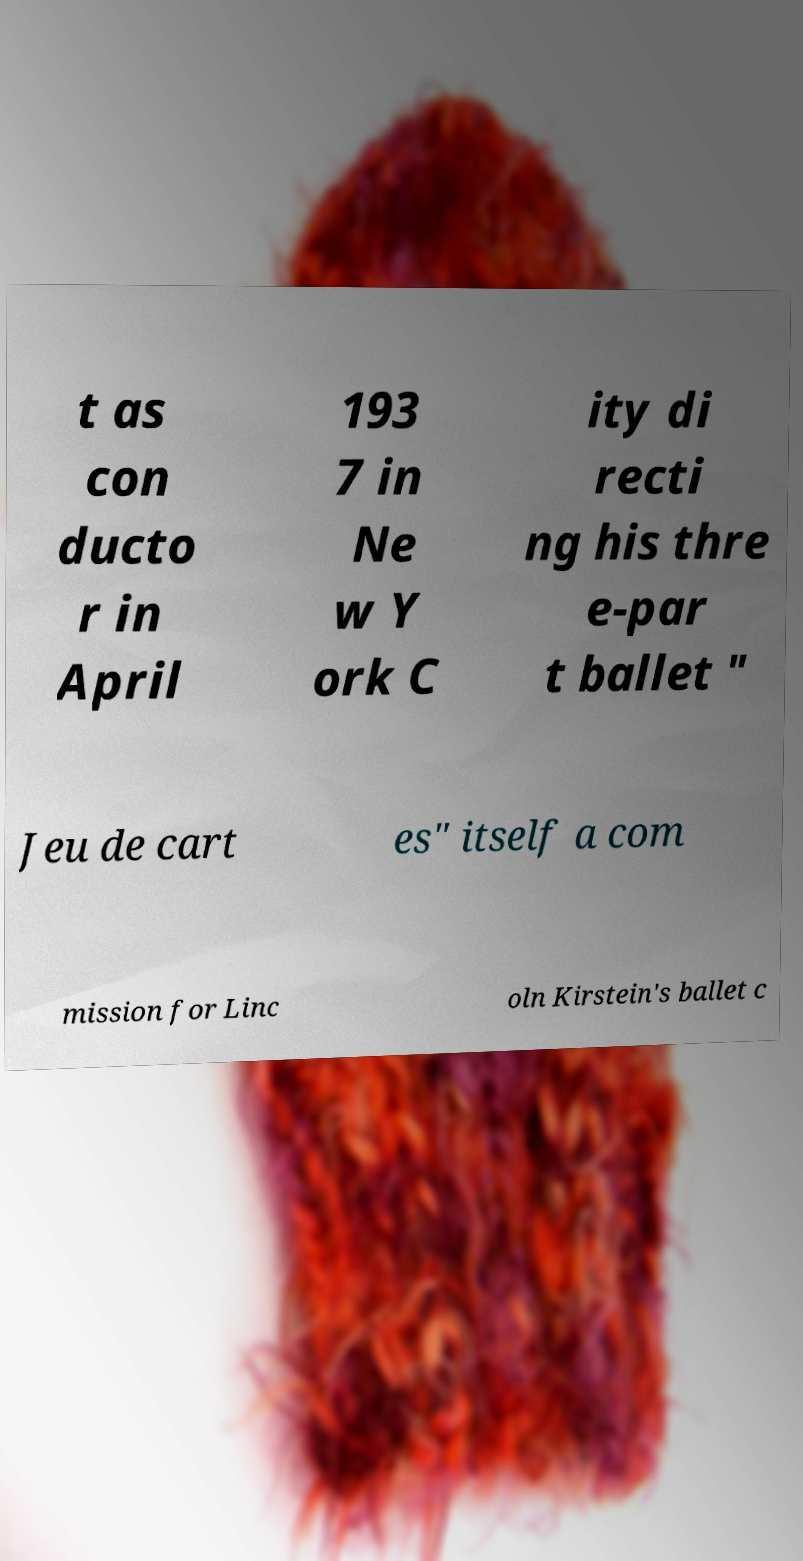What messages or text are displayed in this image? I need them in a readable, typed format. t as con ducto r in April 193 7 in Ne w Y ork C ity di recti ng his thre e-par t ballet " Jeu de cart es" itself a com mission for Linc oln Kirstein's ballet c 